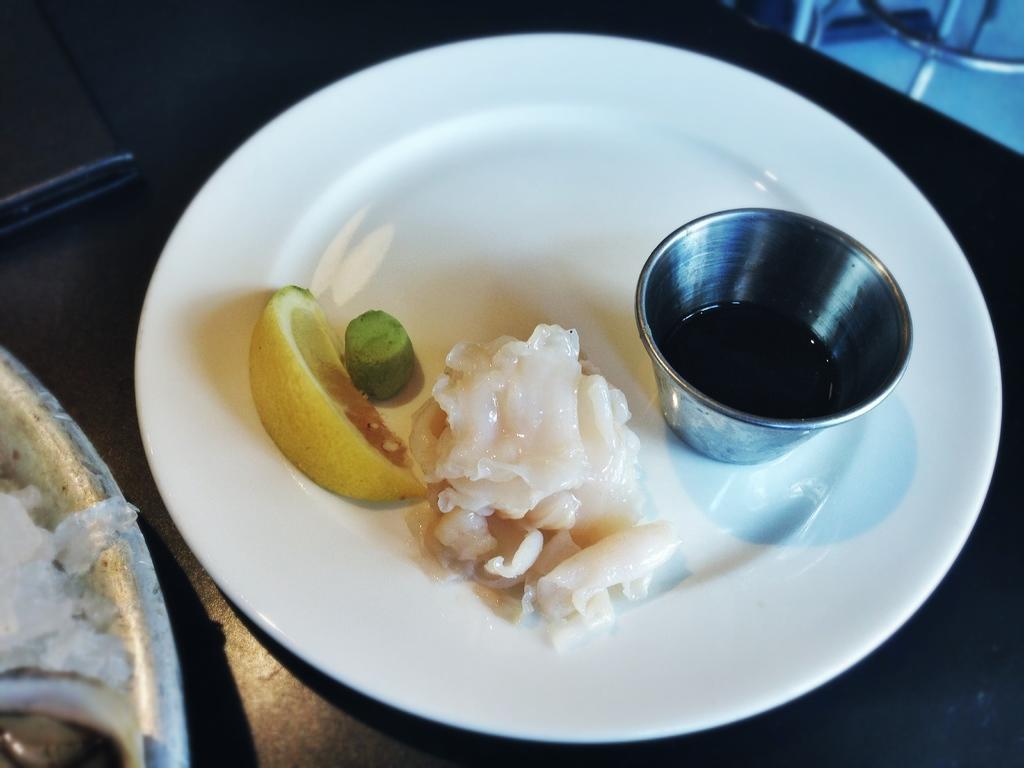Please provide a concise description of this image. In this image we can see a bowl with liquid and food in a plate which is on a platform. On the left side of the image we can see objects which are truncated. 